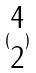Convert formula to latex. <formula><loc_0><loc_0><loc_500><loc_500>( \begin{matrix} 4 \\ 2 \end{matrix} )</formula> 